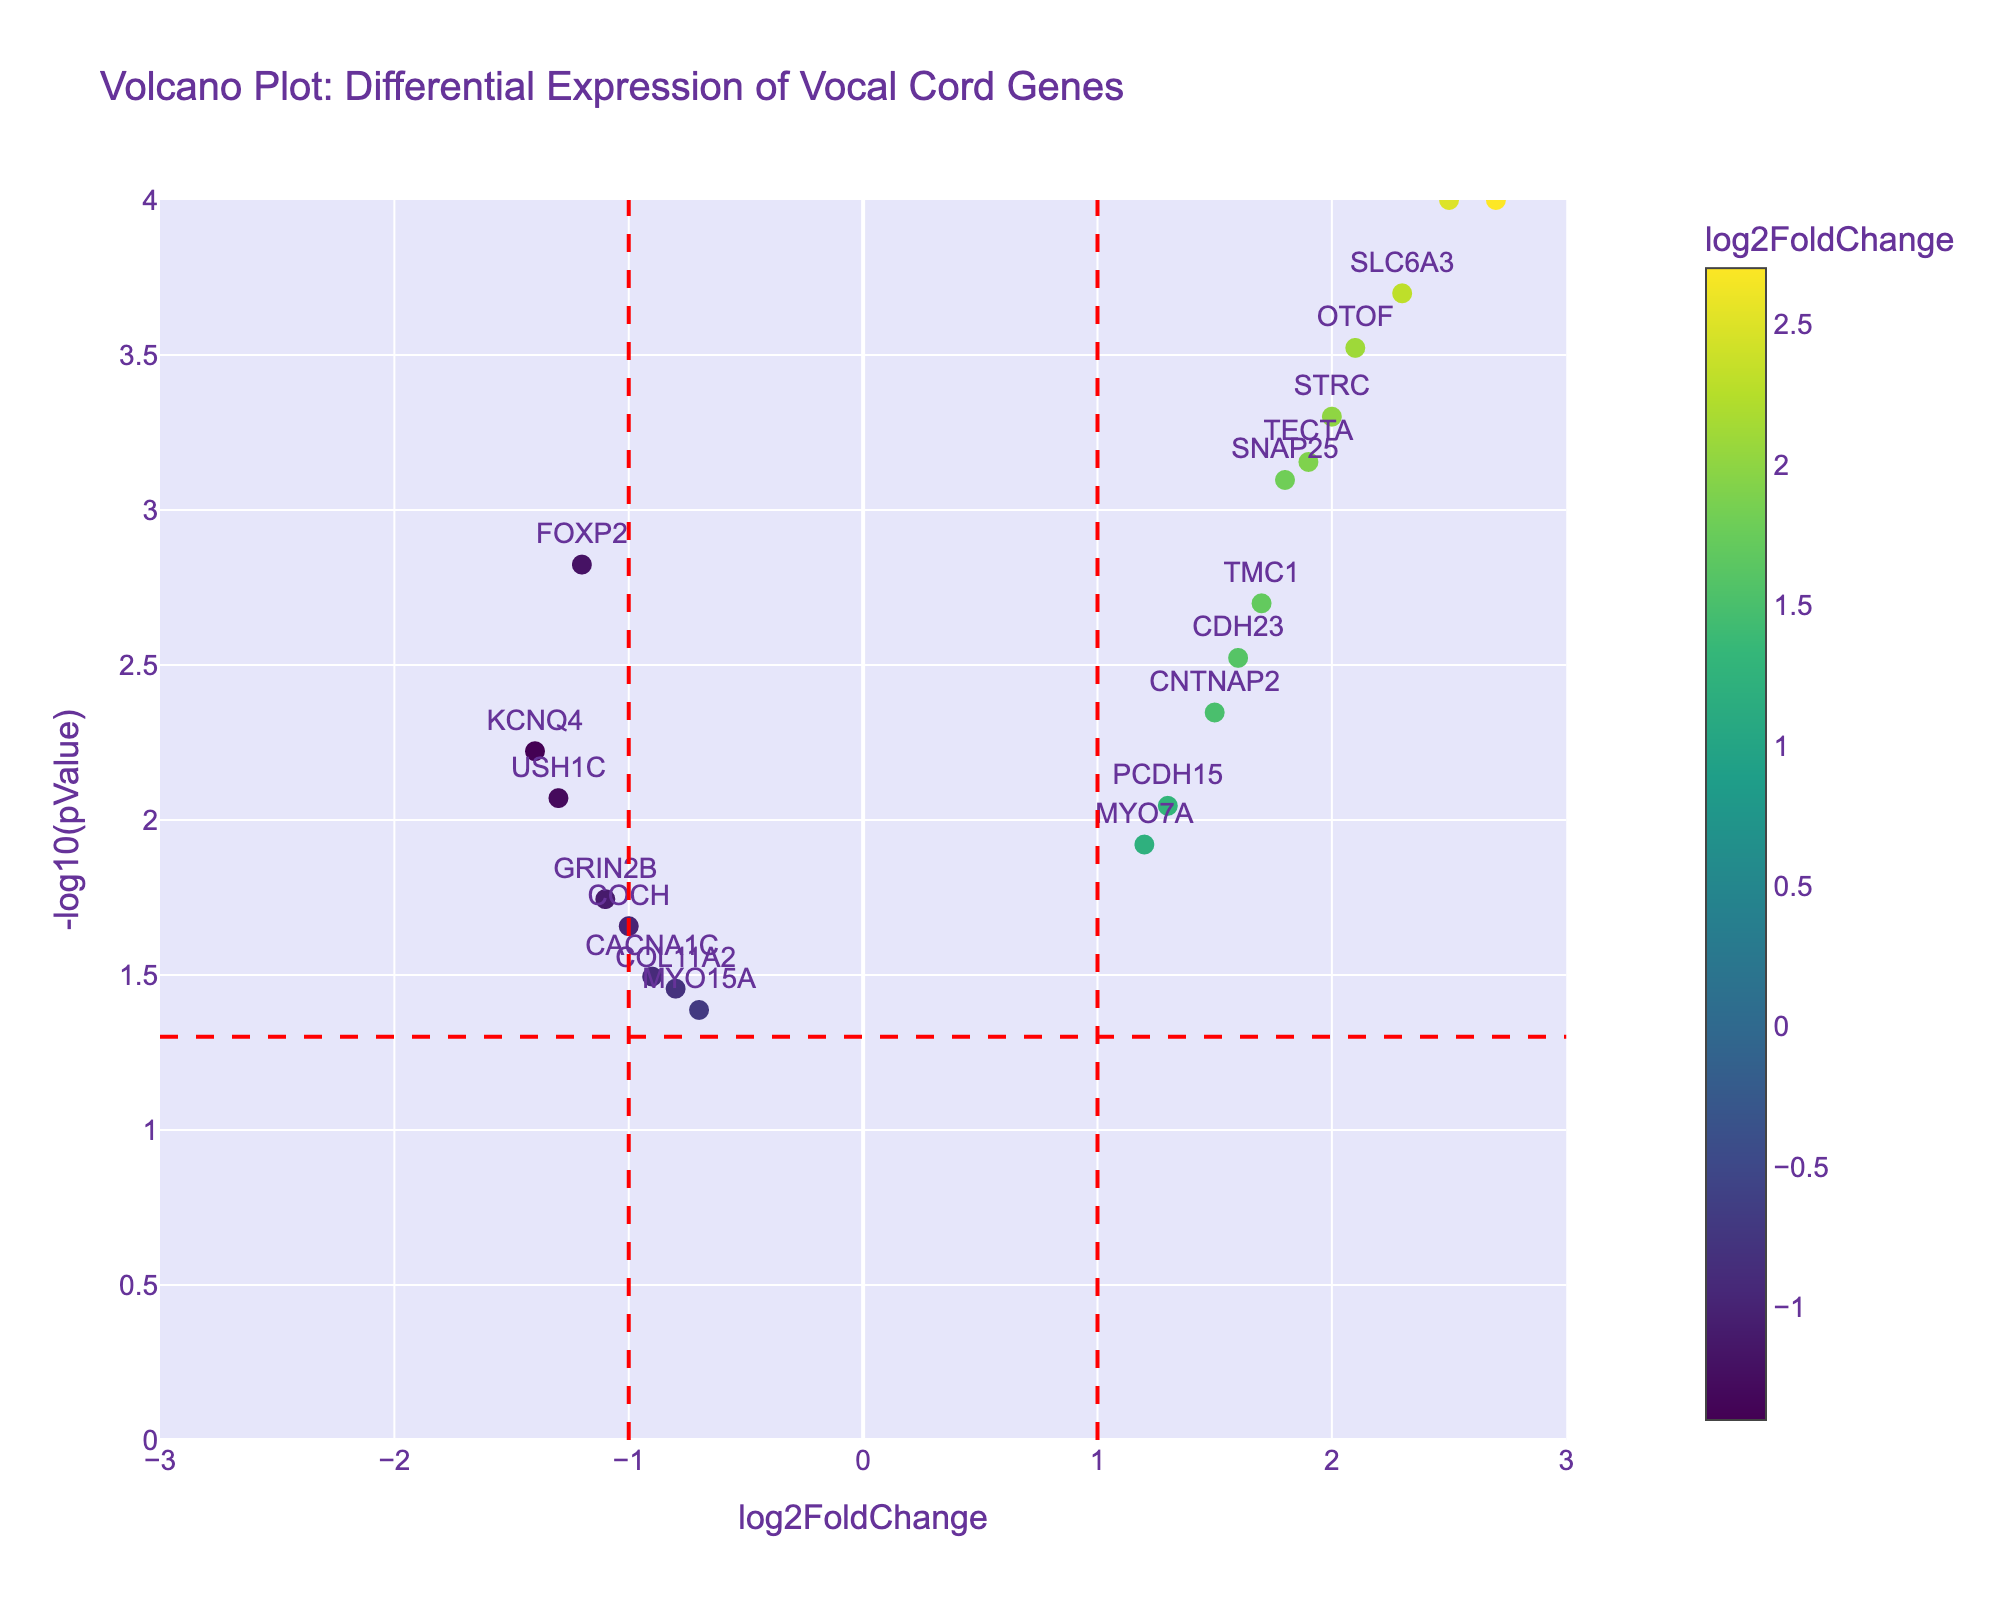How many genes are shown in the volcano plot? Each dot represents one gene, and there are 19 distinct genes in the dataset.
Answer: 19 What is the y-axis title in the volcano plot? The y-axis title is displayed as "-log10(pValue)." This indicates that the y-axis measures the negative logarithm (base 10) of the p-values.
Answer: -log10(pValue) Which gene has the highest absolute log2FoldChange? By inspecting the x-axis and hovering over the points, we can see that BDNF has the highest absolute log2FoldChange value of 2.7, which is the highest among all data points.
Answer: BDNF Which gene has the smallest p-value? The smallest p-value corresponds to the highest value on the y-axis (-log10(pValue)), which is displayed as "SMPX" and "BDNF," both with a -log10(pValue) around 4.
Answer: SMPX and BDNF What are the colors of the vertical and horizontal dashed lines? By examining the visual elements, the vertical and horizontal dashed lines are colored red, indicating significant thresholds in the plot.
Answer: Red How many genes have a log2FoldChange greater than 1 and a p-value less than 0.05? We look at the data points to the right of the vertical line at log2FoldChange = 1 and above the horizontal line at -log10(pValue) = 1.301 (which corresponds to p-value = 0.05). These are BDNF, SLC6A3, SNAP25, TECTA, SMPX, OTOF, TMC1, STRC, CDH23, and MYO7A.
Answer: 10 Which gene is closest to the point where log2FoldChange equals zero? By visually inspecting the plot and identifying the gene closest to the y-axis where log2FoldChange is zero, MYO15A appears closest.
Answer: MYO15A Which gene has the highest -log10(pValue) among those with a negative log2FoldChange? Focusing only on the data points on the left side of log2FoldChange = 0, FOXP2 has the highest -log10(pValue), making it the most significant among negatively regulated genes.
Answer: FOXP2 What is the threshold value for log2FoldChange that is considered significant in this plot? The vertical dashed red lines are at log2FoldChange equal to -1 and 1, which are the significant thresholds in the plot.
Answer: ±1 Which gene has the highest fold change in trained singers compared to non-singers? Looking for the gene with the maximum positive log2FoldChange value, BDNF has the highest fold change with a log2FoldChange of 2.7.
Answer: BDNF 